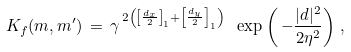Convert formula to latex. <formula><loc_0><loc_0><loc_500><loc_500>K _ { f } ( { m } , { m } ^ { \prime } ) \, = \, \gamma ^ { \, 2 \left ( \left [ \frac { d _ { x } } { 2 } \right ] _ { 1 } + \left [ \frac { d _ { y } } { 2 } \right ] _ { 1 } \right ) } \ \exp \left ( \, - \frac { | { d } | ^ { 2 } } { 2 \eta ^ { 2 } } \right ) \, ,</formula> 